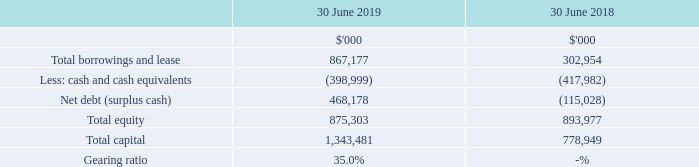Capital and financial risk management
13 Capital risk management
The Group's objectives when managing capital are to safeguard its ability to continue as a going concern, so that it can continue to provide returns to its shareholders and benefits to its stakeholders and to maintain an optimal capital structure to reduce the cost of capital.
In the future, the Directors may pursue funding options such as debt, sale and leaseback of assets, additional equity and various other funding mechanisms as appropriate in order to undertake its projects and deliver optimum shareholders’ return.
The Group intends to maintain a gearing ratio appropriate for a company of its size and growth.
The Group manages its capital structure by regularly reviewing its gearing ratio to ensure it maintains an appropriate level of gearing within facility covenants. This ratio is calculated as net debt divided by total capital. Net debt is calculated as total interest bearing financial liabilities, less cash and cash equivalents. Total capital is calculated as equity, as shown in the Consolidated Balance Sheet, plus net debt.
How does the Group manages its capital structure ? By regularly reviewing its gearing ratio to ensure it maintains an appropriate level of gearing within facility covenants. What is the gearing ratio in 2019? 35.0%. How much was the total capital in 2018?
Answer scale should be: thousand. 778,949. What was the percentage change in total capital between 2018 and 2019?
Answer scale should be: percent. (1,343,481 - 778,949) / 778,949 
Answer: 72.47. What was the percentage of total equity among total capital in 2019?
Answer scale should be: percent. 875,303 / 1,343,481 
Answer: 65.15. What was the percentage change in total borrowings and lease between 2018 and 2019?
Answer scale should be: percent. (867,177 - 302,954) / 302,954 
Answer: 186.24. 